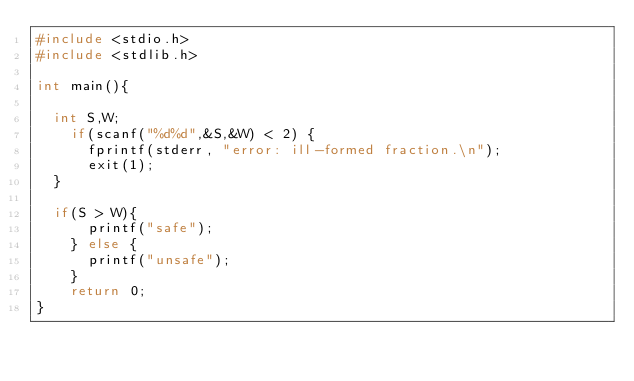Convert code to text. <code><loc_0><loc_0><loc_500><loc_500><_C_>#include <stdio.h>
#include <stdlib.h>
 
int main(){
 
	int S,W;
  	if(scanf("%d%d",&S,&W) < 2) {
    	fprintf(stderr, "error: ill-formed fraction.\n");
    	exit(1);
	}
  
	if(S > W){
    	printf("safe");
    } else {
    	printf("unsafe");
    }
  	return 0;
}</code> 